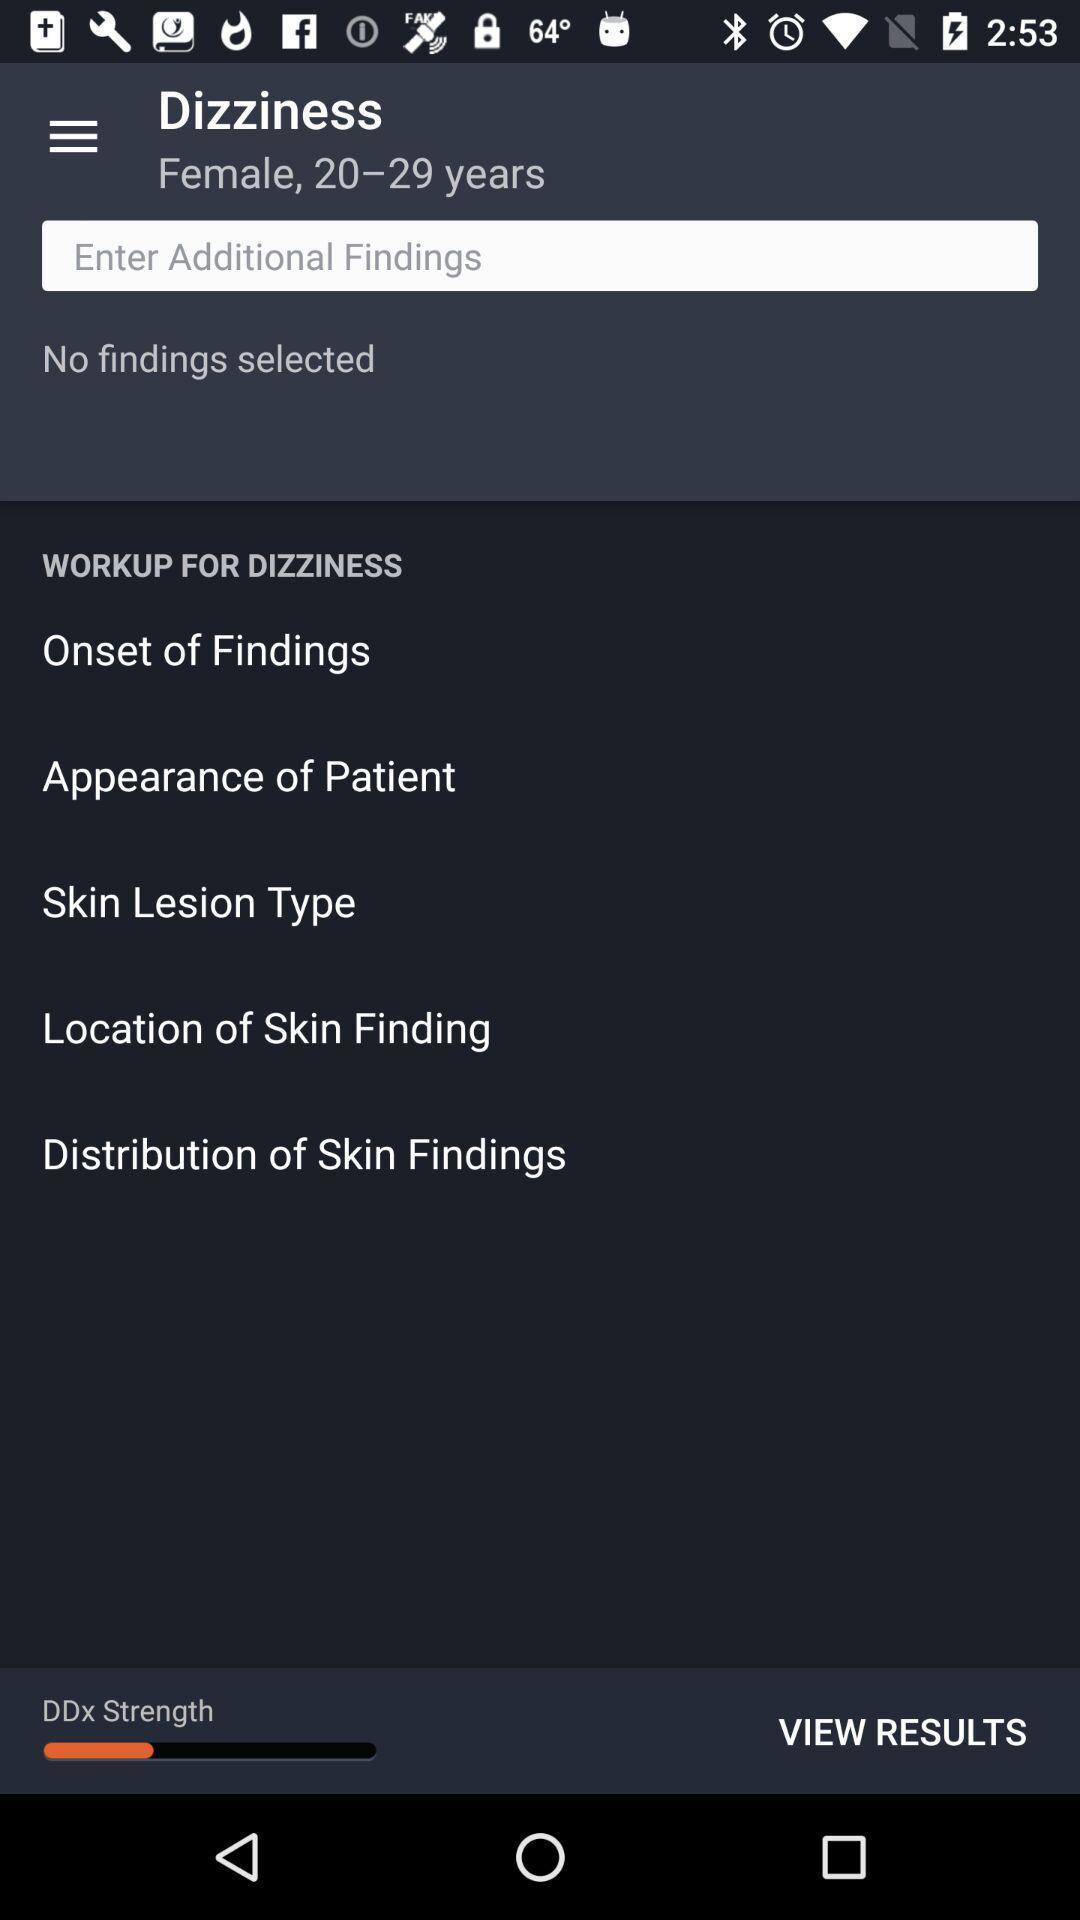Describe the visual elements of this screenshot. Various filters displayed of a health care hygiene app. 